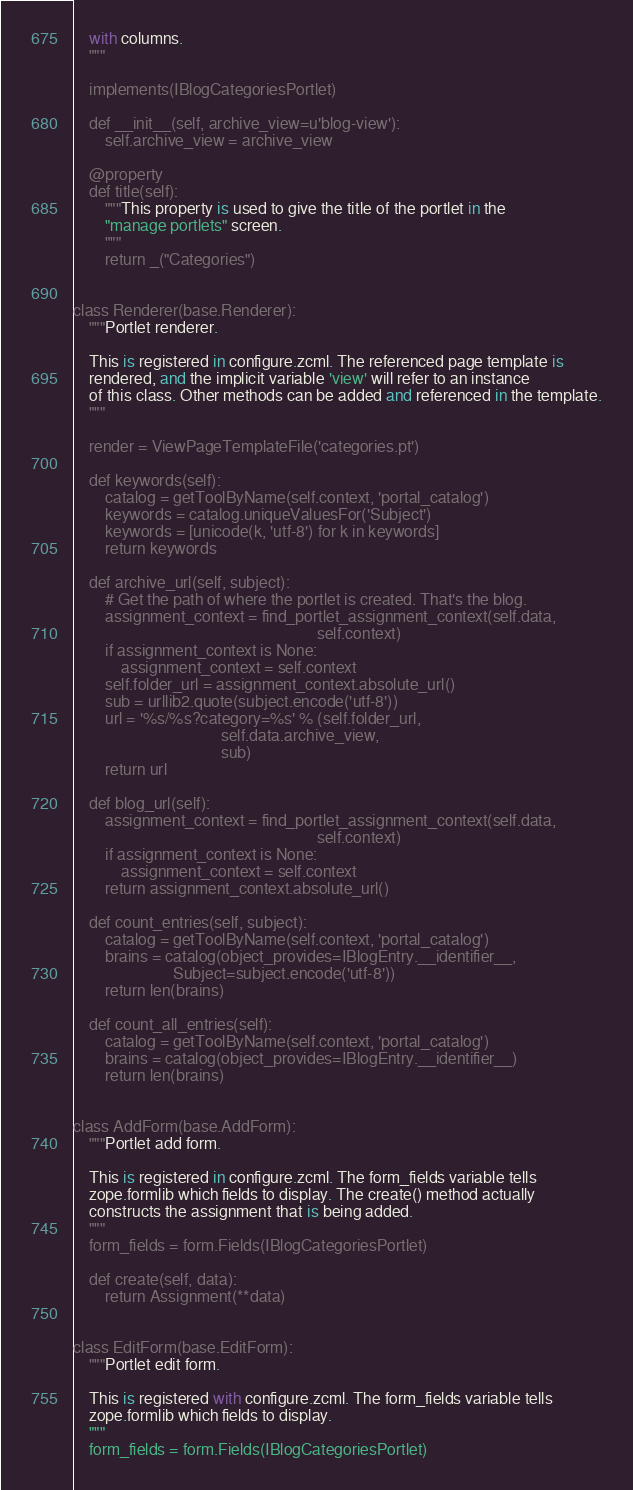<code> <loc_0><loc_0><loc_500><loc_500><_Python_>    with columns.
    """

    implements(IBlogCategoriesPortlet)

    def __init__(self, archive_view=u'blog-view'):
        self.archive_view = archive_view

    @property
    def title(self):
        """This property is used to give the title of the portlet in the
        "manage portlets" screen.
        """
        return _("Categories")


class Renderer(base.Renderer):
    """Portlet renderer.

    This is registered in configure.zcml. The referenced page template is
    rendered, and the implicit variable 'view' will refer to an instance
    of this class. Other methods can be added and referenced in the template.
    """

    render = ViewPageTemplateFile('categories.pt')

    def keywords(self):
        catalog = getToolByName(self.context, 'portal_catalog')
        keywords = catalog.uniqueValuesFor('Subject')
        keywords = [unicode(k, 'utf-8') for k in keywords]
        return keywords

    def archive_url(self, subject):
        # Get the path of where the portlet is created. That's the blog.
        assignment_context = find_portlet_assignment_context(self.data,
                                                             self.context)
        if assignment_context is None:
            assignment_context = self.context
        self.folder_url = assignment_context.absolute_url()
        sub = urllib2.quote(subject.encode('utf-8'))
        url = '%s/%s?category=%s' % (self.folder_url,
                                     self.data.archive_view,
                                     sub)
        return url

    def blog_url(self):
        assignment_context = find_portlet_assignment_context(self.data,
                                                             self.context)
        if assignment_context is None:
            assignment_context = self.context
        return assignment_context.absolute_url()

    def count_entries(self, subject):
        catalog = getToolByName(self.context, 'portal_catalog')
        brains = catalog(object_provides=IBlogEntry.__identifier__,
                         Subject=subject.encode('utf-8'))
        return len(brains)

    def count_all_entries(self):
        catalog = getToolByName(self.context, 'portal_catalog')
        brains = catalog(object_provides=IBlogEntry.__identifier__)
        return len(brains)


class AddForm(base.AddForm):
    """Portlet add form.

    This is registered in configure.zcml. The form_fields variable tells
    zope.formlib which fields to display. The create() method actually
    constructs the assignment that is being added.
    """
    form_fields = form.Fields(IBlogCategoriesPortlet)

    def create(self, data):
        return Assignment(**data)


class EditForm(base.EditForm):
    """Portlet edit form.

    This is registered with configure.zcml. The form_fields variable tells
    zope.formlib which fields to display.
    """
    form_fields = form.Fields(IBlogCategoriesPortlet)
</code> 